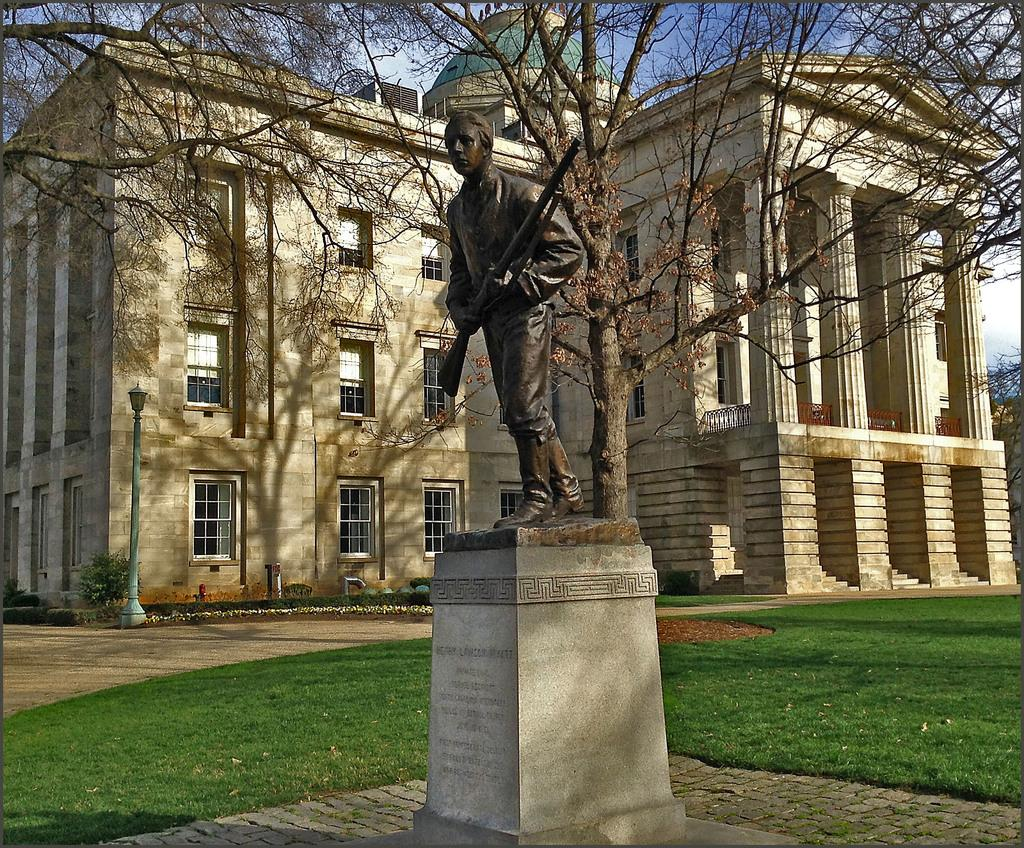What is the main subject in the center of the image? There is a statue in the center of the image. What can be seen in the background of the image? There is a building, trees, a light pole, plants, a path, and grass in the background of the image. What part of the natural environment is visible in the image? The grass and trees are visible in the background of the image. What is visible in the sky in the image? The sky is visible in the image. What type of egg is being cooked on the kettle in the image? There is no kettle or egg present in the image. Can you tell me where the sister is standing in the image? There is no mention of a sister in the image, so we cannot determine her location. 